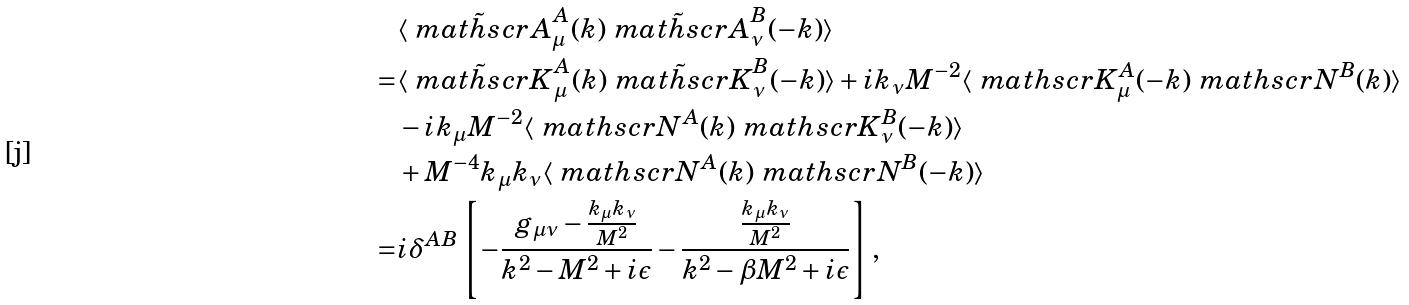<formula> <loc_0><loc_0><loc_500><loc_500>& \langle \tilde { \ m a t h s c r { A } } ^ { A } _ { \mu } ( k ) \tilde { \ m a t h s c r { A } } ^ { B } _ { \nu } ( - k ) \rangle \\ = & \langle \tilde { \ m a t h s c r { K } } ^ { A } _ { \mu } ( k ) \tilde { \ m a t h s c r { K } } ^ { B } _ { \nu } ( - k ) \rangle + i k _ { \nu } M ^ { - 2 } \langle \ m a t h s c r { K } _ { \mu } ^ { A } ( - k ) \ m a t h s c r { N } ^ { B } ( k ) \rangle \\ & - i k _ { \mu } M ^ { - 2 } \langle \ m a t h s c r { N } ^ { A } ( k ) \ m a t h s c r { K } _ { \nu } ^ { B } ( - k ) \rangle \\ & + M ^ { - 4 } k _ { \mu } k _ { \nu } \langle \ m a t h s c r { N } ^ { A } ( k ) \ m a t h s c r { N } ^ { B } ( - k ) \rangle \\ = & i \delta ^ { A B } \left [ - \frac { g _ { \mu \nu } - \frac { k _ { \mu } k _ { \nu } } { M ^ { 2 } } } { k ^ { 2 } - M ^ { 2 } + i \epsilon } - \frac { \frac { k _ { \mu } k _ { \nu } } { M ^ { 2 } } } { k ^ { 2 } - \beta M ^ { 2 } + i \epsilon } \right ] ,</formula> 